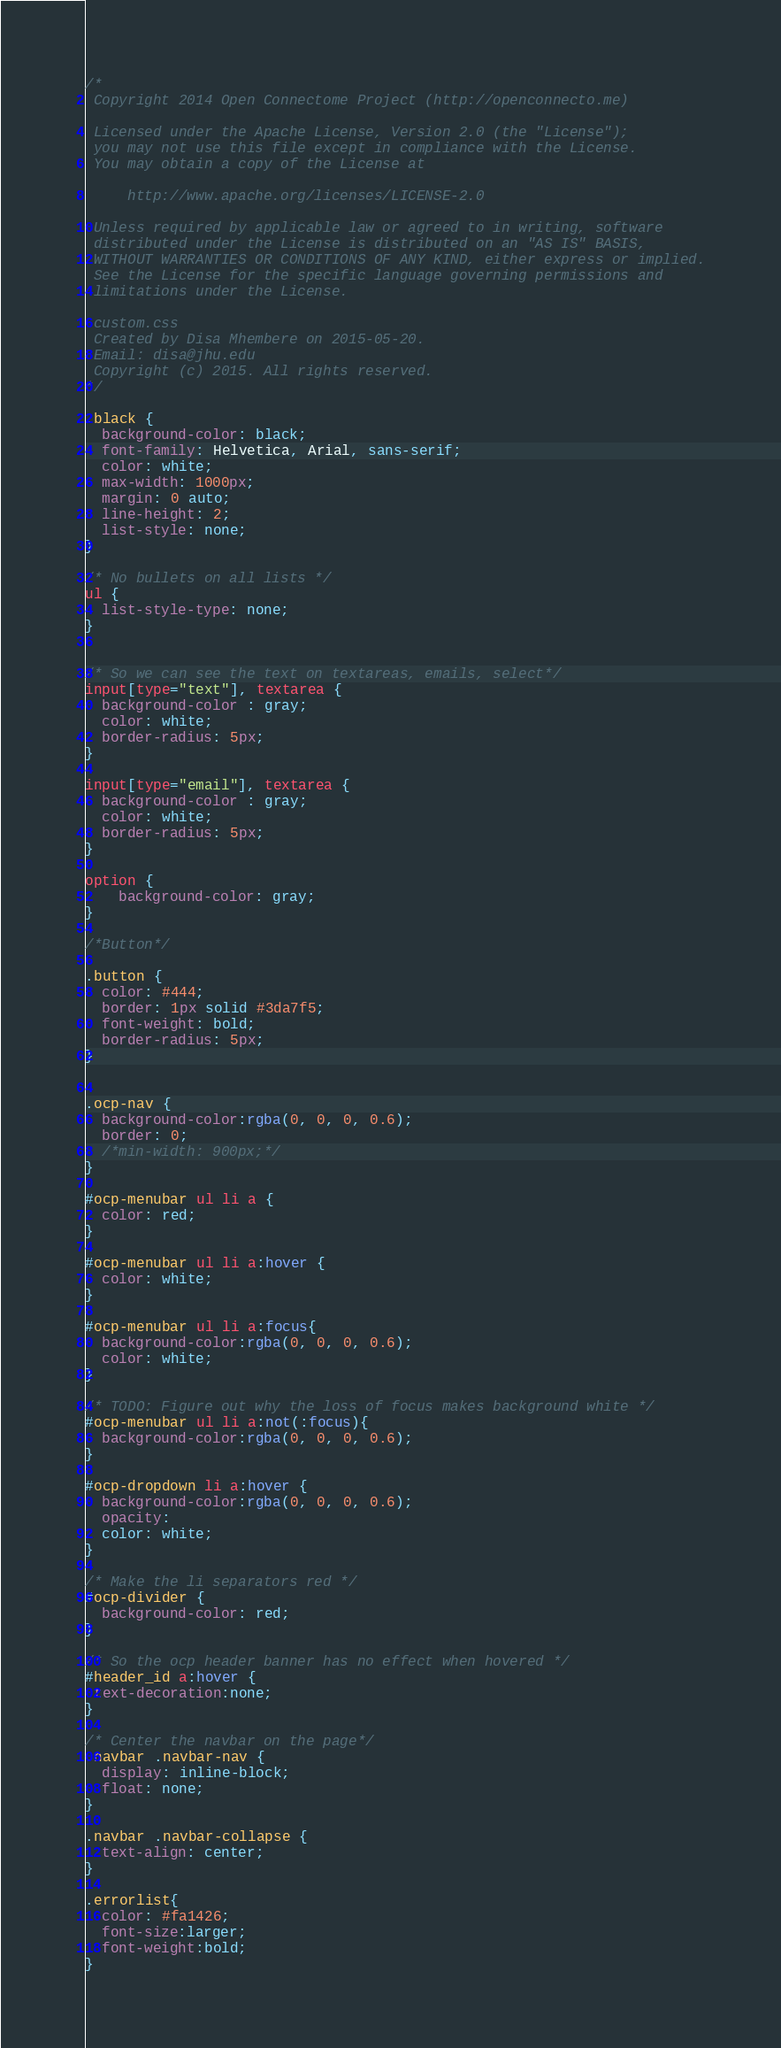<code> <loc_0><loc_0><loc_500><loc_500><_CSS_>/*
 Copyright 2014 Open Connectome Project (http://openconnecto.me)

 Licensed under the Apache License, Version 2.0 (the "License");
 you may not use this file except in compliance with the License.
 You may obtain a copy of the License at

     http://www.apache.org/licenses/LICENSE-2.0

 Unless required by applicable law or agreed to in writing, software
 distributed under the License is distributed on an "AS IS" BASIS,
 WITHOUT WARRANTIES OR CONDITIONS OF ANY KIND, either express or implied.
 See the License for the specific language governing permissions and
 limitations under the License.

 custom.css
 Created by Disa Mhembere on 2015-05-20.
 Email: disa@jhu.edu
 Copyright (c) 2015. All rights reserved.
*/

.black {
  background-color: black;
  font-family: Helvetica, Arial, sans-serif;
  color: white;
  max-width: 1000px;
  margin: 0 auto;
  line-height: 2;
  list-style: none;
}

/* No bullets on all lists */
ul {
  list-style-type: none;
}


/* So we can see the text on textareas, emails, select*/
input[type="text"], textarea {
  background-color : gray; 
  color: white;
  border-radius: 5px;
}

input[type="email"], textarea {
  background-color : gray; 
  color: white;
  border-radius: 5px;
}

option {
    background-color: gray;
}

/*Button*/

.button {
  color: #444;
  border: 1px solid #3da7f5;
  font-weight: bold;
  border-radius: 5px;
}


.ocp-nav {
  background-color:rgba(0, 0, 0, 0.6);
  border: 0;
  /*min-width: 900px;*/
}

#ocp-menubar ul li a { 
  color: red;
}

#ocp-menubar ul li a:hover { 
  color: white;
}

#ocp-menubar ul li a:focus{ 
  background-color:rgba(0, 0, 0, 0.6);
  color: white;
}

/* TODO: Figure out why the loss of focus makes background white */
#ocp-menubar ul li a:not(:focus){
  background-color:rgba(0, 0, 0, 0.6);
}

#ocp-dropdown li a:hover { 
  background-color:rgba(0, 0, 0, 0.6);
  opacity: 
  color: white;
}

/* Make the li separators red */
#ocp-divider {
  background-color: red;
}

/* So the ocp header banner has no effect when hovered */
#header_id a:hover {
 text-decoration:none;
}

/* Center the navbar on the page*/
.navbar .navbar-nav {
  display: inline-block;
  float: none;
}

.navbar .navbar-collapse {
  text-align: center;
}

.errorlist{
  color: #fa1426;
  font-size:larger;
  font-weight:bold;
}

</code> 